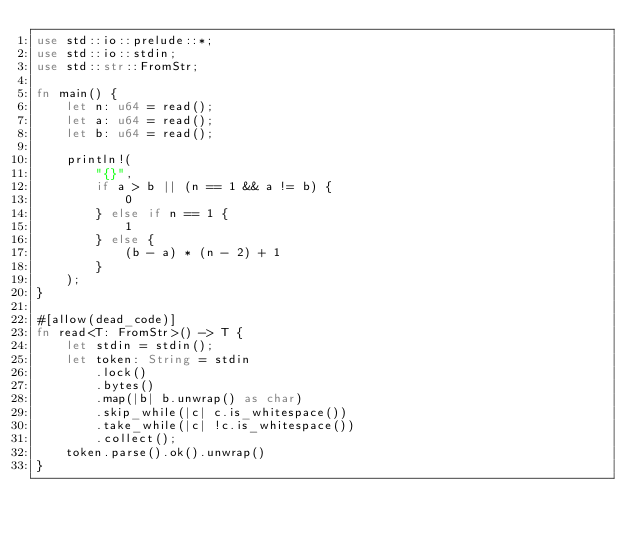<code> <loc_0><loc_0><loc_500><loc_500><_Rust_>use std::io::prelude::*;
use std::io::stdin;
use std::str::FromStr;

fn main() {
    let n: u64 = read();
    let a: u64 = read();
    let b: u64 = read();

    println!(
        "{}",
        if a > b || (n == 1 && a != b) {
            0
        } else if n == 1 {
            1
        } else {
            (b - a) * (n - 2) + 1
        }
    );
}

#[allow(dead_code)]
fn read<T: FromStr>() -> T {
    let stdin = stdin();
    let token: String = stdin
        .lock()
        .bytes()
        .map(|b| b.unwrap() as char)
        .skip_while(|c| c.is_whitespace())
        .take_while(|c| !c.is_whitespace())
        .collect();
    token.parse().ok().unwrap()
}
</code> 